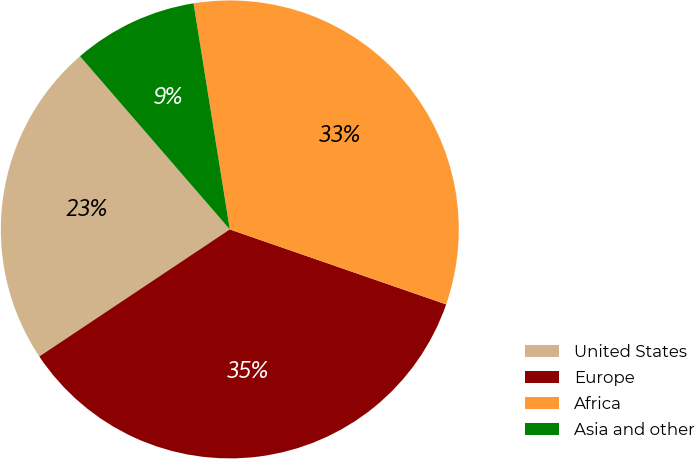<chart> <loc_0><loc_0><loc_500><loc_500><pie_chart><fcel>United States<fcel>Europe<fcel>Africa<fcel>Asia and other<nl><fcel>23.01%<fcel>35.33%<fcel>32.84%<fcel>8.82%<nl></chart> 